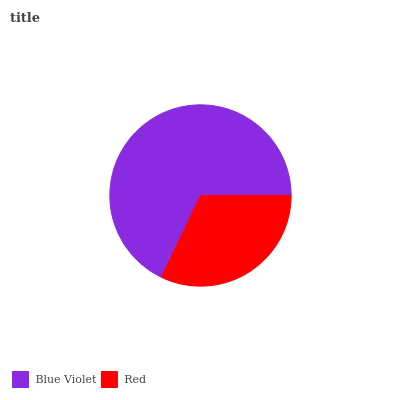Is Red the minimum?
Answer yes or no. Yes. Is Blue Violet the maximum?
Answer yes or no. Yes. Is Red the maximum?
Answer yes or no. No. Is Blue Violet greater than Red?
Answer yes or no. Yes. Is Red less than Blue Violet?
Answer yes or no. Yes. Is Red greater than Blue Violet?
Answer yes or no. No. Is Blue Violet less than Red?
Answer yes or no. No. Is Blue Violet the high median?
Answer yes or no. Yes. Is Red the low median?
Answer yes or no. Yes. Is Red the high median?
Answer yes or no. No. Is Blue Violet the low median?
Answer yes or no. No. 